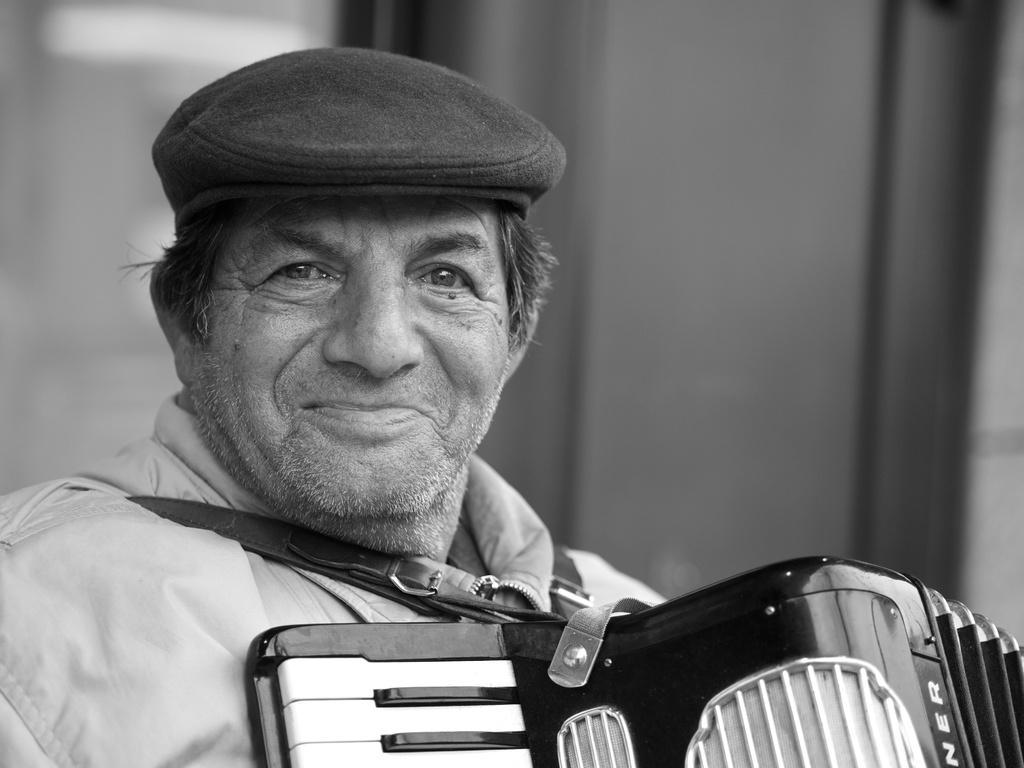Describe this image in one or two sentences. In this picture I can see a person with a smile and wearing the cap. I can see musical instrument. 